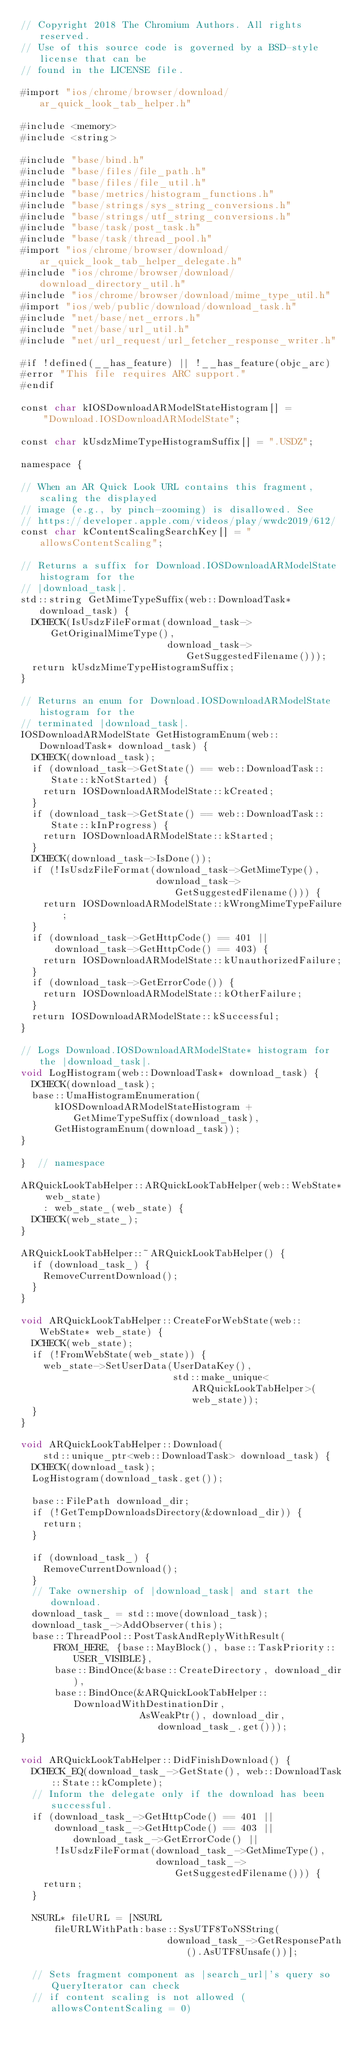<code> <loc_0><loc_0><loc_500><loc_500><_ObjectiveC_>// Copyright 2018 The Chromium Authors. All rights reserved.
// Use of this source code is governed by a BSD-style license that can be
// found in the LICENSE file.

#import "ios/chrome/browser/download/ar_quick_look_tab_helper.h"

#include <memory>
#include <string>

#include "base/bind.h"
#include "base/files/file_path.h"
#include "base/files/file_util.h"
#include "base/metrics/histogram_functions.h"
#include "base/strings/sys_string_conversions.h"
#include "base/strings/utf_string_conversions.h"
#include "base/task/post_task.h"
#include "base/task/thread_pool.h"
#import "ios/chrome/browser/download/ar_quick_look_tab_helper_delegate.h"
#include "ios/chrome/browser/download/download_directory_util.h"
#include "ios/chrome/browser/download/mime_type_util.h"
#import "ios/web/public/download/download_task.h"
#include "net/base/net_errors.h"
#include "net/base/url_util.h"
#include "net/url_request/url_fetcher_response_writer.h"

#if !defined(__has_feature) || !__has_feature(objc_arc)
#error "This file requires ARC support."
#endif

const char kIOSDownloadARModelStateHistogram[] =
    "Download.IOSDownloadARModelState";

const char kUsdzMimeTypeHistogramSuffix[] = ".USDZ";

namespace {

// When an AR Quick Look URL contains this fragment, scaling the displayed
// image (e.g., by pinch-zooming) is disallowed. See
// https://developer.apple.com/videos/play/wwdc2019/612/
const char kContentScalingSearchKey[] = "allowsContentScaling";

// Returns a suffix for Download.IOSDownloadARModelState histogram for the
// |download_task|.
std::string GetMimeTypeSuffix(web::DownloadTask* download_task) {
  DCHECK(IsUsdzFileFormat(download_task->GetOriginalMimeType(),
                          download_task->GetSuggestedFilename()));
  return kUsdzMimeTypeHistogramSuffix;
}

// Returns an enum for Download.IOSDownloadARModelState histogram for the
// terminated |download_task|.
IOSDownloadARModelState GetHistogramEnum(web::DownloadTask* download_task) {
  DCHECK(download_task);
  if (download_task->GetState() == web::DownloadTask::State::kNotStarted) {
    return IOSDownloadARModelState::kCreated;
  }
  if (download_task->GetState() == web::DownloadTask::State::kInProgress) {
    return IOSDownloadARModelState::kStarted;
  }
  DCHECK(download_task->IsDone());
  if (!IsUsdzFileFormat(download_task->GetMimeType(),
                        download_task->GetSuggestedFilename())) {
    return IOSDownloadARModelState::kWrongMimeTypeFailure;
  }
  if (download_task->GetHttpCode() == 401 ||
      download_task->GetHttpCode() == 403) {
    return IOSDownloadARModelState::kUnauthorizedFailure;
  }
  if (download_task->GetErrorCode()) {
    return IOSDownloadARModelState::kOtherFailure;
  }
  return IOSDownloadARModelState::kSuccessful;
}

// Logs Download.IOSDownloadARModelState* histogram for the |download_task|.
void LogHistogram(web::DownloadTask* download_task) {
  DCHECK(download_task);
  base::UmaHistogramEnumeration(
      kIOSDownloadARModelStateHistogram + GetMimeTypeSuffix(download_task),
      GetHistogramEnum(download_task));
}

}  // namespace

ARQuickLookTabHelper::ARQuickLookTabHelper(web::WebState* web_state)
    : web_state_(web_state) {
  DCHECK(web_state_);
}

ARQuickLookTabHelper::~ARQuickLookTabHelper() {
  if (download_task_) {
    RemoveCurrentDownload();
  }
}

void ARQuickLookTabHelper::CreateForWebState(web::WebState* web_state) {
  DCHECK(web_state);
  if (!FromWebState(web_state)) {
    web_state->SetUserData(UserDataKey(),
                           std::make_unique<ARQuickLookTabHelper>(web_state));
  }
}

void ARQuickLookTabHelper::Download(
    std::unique_ptr<web::DownloadTask> download_task) {
  DCHECK(download_task);
  LogHistogram(download_task.get());

  base::FilePath download_dir;
  if (!GetTempDownloadsDirectory(&download_dir)) {
    return;
  }

  if (download_task_) {
    RemoveCurrentDownload();
  }
  // Take ownership of |download_task| and start the download.
  download_task_ = std::move(download_task);
  download_task_->AddObserver(this);
  base::ThreadPool::PostTaskAndReplyWithResult(
      FROM_HERE, {base::MayBlock(), base::TaskPriority::USER_VISIBLE},
      base::BindOnce(&base::CreateDirectory, download_dir),
      base::BindOnce(&ARQuickLookTabHelper::DownloadWithDestinationDir,
                     AsWeakPtr(), download_dir, download_task_.get()));
}

void ARQuickLookTabHelper::DidFinishDownload() {
  DCHECK_EQ(download_task_->GetState(), web::DownloadTask::State::kComplete);
  // Inform the delegate only if the download has been successful.
  if (download_task_->GetHttpCode() == 401 ||
      download_task_->GetHttpCode() == 403 || download_task_->GetErrorCode() ||
      !IsUsdzFileFormat(download_task_->GetMimeType(),
                        download_task_->GetSuggestedFilename())) {
    return;
  }

  NSURL* fileURL = [NSURL
      fileURLWithPath:base::SysUTF8ToNSString(
                          download_task_->GetResponsePath().AsUTF8Unsafe())];

  // Sets fragment component as |search_url|'s query so QueryIterator can check
  // if content scaling is not allowed (allowsContentScaling = 0)</code> 